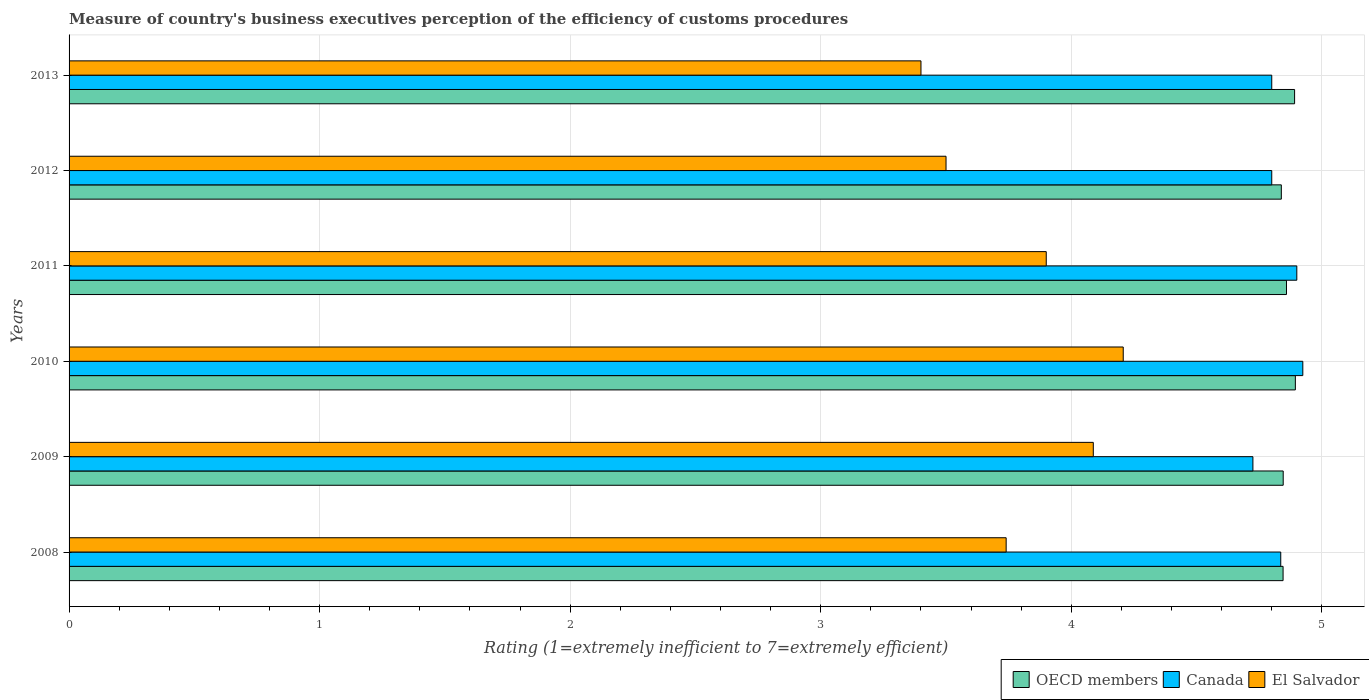How many groups of bars are there?
Provide a short and direct response. 6. Are the number of bars per tick equal to the number of legend labels?
Provide a short and direct response. Yes. In how many cases, is the number of bars for a given year not equal to the number of legend labels?
Give a very brief answer. 0. What is the rating of the efficiency of customs procedure in Canada in 2011?
Your answer should be compact. 4.9. Across all years, what is the maximum rating of the efficiency of customs procedure in Canada?
Keep it short and to the point. 4.92. What is the total rating of the efficiency of customs procedure in El Salvador in the graph?
Give a very brief answer. 22.84. What is the difference between the rating of the efficiency of customs procedure in OECD members in 2009 and that in 2010?
Ensure brevity in your answer.  -0.05. What is the difference between the rating of the efficiency of customs procedure in El Salvador in 2011 and the rating of the efficiency of customs procedure in Canada in 2013?
Provide a succinct answer. -0.9. What is the average rating of the efficiency of customs procedure in El Salvador per year?
Your response must be concise. 3.81. In the year 2010, what is the difference between the rating of the efficiency of customs procedure in OECD members and rating of the efficiency of customs procedure in Canada?
Your response must be concise. -0.03. What is the ratio of the rating of the efficiency of customs procedure in Canada in 2010 to that in 2011?
Give a very brief answer. 1. What is the difference between the highest and the second highest rating of the efficiency of customs procedure in El Salvador?
Provide a succinct answer. 0.12. What is the difference between the highest and the lowest rating of the efficiency of customs procedure in El Salvador?
Offer a very short reply. 0.81. In how many years, is the rating of the efficiency of customs procedure in OECD members greater than the average rating of the efficiency of customs procedure in OECD members taken over all years?
Provide a short and direct response. 2. What does the 2nd bar from the top in 2012 represents?
Your answer should be very brief. Canada. How many bars are there?
Your answer should be compact. 18. How many years are there in the graph?
Provide a succinct answer. 6. Does the graph contain any zero values?
Provide a short and direct response. No. Where does the legend appear in the graph?
Your response must be concise. Bottom right. How many legend labels are there?
Offer a very short reply. 3. What is the title of the graph?
Ensure brevity in your answer.  Measure of country's business executives perception of the efficiency of customs procedures. What is the label or title of the X-axis?
Ensure brevity in your answer.  Rating (1=extremely inefficient to 7=extremely efficient). What is the Rating (1=extremely inefficient to 7=extremely efficient) of OECD members in 2008?
Offer a terse response. 4.85. What is the Rating (1=extremely inefficient to 7=extremely efficient) in Canada in 2008?
Keep it short and to the point. 4.84. What is the Rating (1=extremely inefficient to 7=extremely efficient) in El Salvador in 2008?
Give a very brief answer. 3.74. What is the Rating (1=extremely inefficient to 7=extremely efficient) of OECD members in 2009?
Offer a terse response. 4.85. What is the Rating (1=extremely inefficient to 7=extremely efficient) of Canada in 2009?
Your answer should be very brief. 4.72. What is the Rating (1=extremely inefficient to 7=extremely efficient) of El Salvador in 2009?
Your answer should be compact. 4.09. What is the Rating (1=extremely inefficient to 7=extremely efficient) of OECD members in 2010?
Give a very brief answer. 4.89. What is the Rating (1=extremely inefficient to 7=extremely efficient) in Canada in 2010?
Offer a terse response. 4.92. What is the Rating (1=extremely inefficient to 7=extremely efficient) of El Salvador in 2010?
Offer a very short reply. 4.21. What is the Rating (1=extremely inefficient to 7=extremely efficient) of OECD members in 2011?
Offer a terse response. 4.86. What is the Rating (1=extremely inefficient to 7=extremely efficient) of OECD members in 2012?
Your answer should be very brief. 4.84. What is the Rating (1=extremely inefficient to 7=extremely efficient) in El Salvador in 2012?
Make the answer very short. 3.5. What is the Rating (1=extremely inefficient to 7=extremely efficient) of OECD members in 2013?
Your response must be concise. 4.89. What is the Rating (1=extremely inefficient to 7=extremely efficient) of El Salvador in 2013?
Your response must be concise. 3.4. Across all years, what is the maximum Rating (1=extremely inefficient to 7=extremely efficient) in OECD members?
Your answer should be compact. 4.89. Across all years, what is the maximum Rating (1=extremely inefficient to 7=extremely efficient) of Canada?
Your answer should be compact. 4.92. Across all years, what is the maximum Rating (1=extremely inefficient to 7=extremely efficient) in El Salvador?
Your answer should be compact. 4.21. Across all years, what is the minimum Rating (1=extremely inefficient to 7=extremely efficient) of OECD members?
Give a very brief answer. 4.84. Across all years, what is the minimum Rating (1=extremely inefficient to 7=extremely efficient) of Canada?
Provide a short and direct response. 4.72. Across all years, what is the minimum Rating (1=extremely inefficient to 7=extremely efficient) in El Salvador?
Provide a succinct answer. 3.4. What is the total Rating (1=extremely inefficient to 7=extremely efficient) in OECD members in the graph?
Your response must be concise. 29.17. What is the total Rating (1=extremely inefficient to 7=extremely efficient) in Canada in the graph?
Keep it short and to the point. 28.98. What is the total Rating (1=extremely inefficient to 7=extremely efficient) in El Salvador in the graph?
Your response must be concise. 22.84. What is the difference between the Rating (1=extremely inefficient to 7=extremely efficient) in OECD members in 2008 and that in 2009?
Keep it short and to the point. -0. What is the difference between the Rating (1=extremely inefficient to 7=extremely efficient) of El Salvador in 2008 and that in 2009?
Make the answer very short. -0.35. What is the difference between the Rating (1=extremely inefficient to 7=extremely efficient) of OECD members in 2008 and that in 2010?
Offer a very short reply. -0.05. What is the difference between the Rating (1=extremely inefficient to 7=extremely efficient) in Canada in 2008 and that in 2010?
Keep it short and to the point. -0.09. What is the difference between the Rating (1=extremely inefficient to 7=extremely efficient) of El Salvador in 2008 and that in 2010?
Keep it short and to the point. -0.47. What is the difference between the Rating (1=extremely inefficient to 7=extremely efficient) of OECD members in 2008 and that in 2011?
Your response must be concise. -0.01. What is the difference between the Rating (1=extremely inefficient to 7=extremely efficient) of Canada in 2008 and that in 2011?
Provide a short and direct response. -0.06. What is the difference between the Rating (1=extremely inefficient to 7=extremely efficient) of El Salvador in 2008 and that in 2011?
Make the answer very short. -0.16. What is the difference between the Rating (1=extremely inefficient to 7=extremely efficient) of OECD members in 2008 and that in 2012?
Your answer should be very brief. 0.01. What is the difference between the Rating (1=extremely inefficient to 7=extremely efficient) of Canada in 2008 and that in 2012?
Provide a succinct answer. 0.04. What is the difference between the Rating (1=extremely inefficient to 7=extremely efficient) of El Salvador in 2008 and that in 2012?
Keep it short and to the point. 0.24. What is the difference between the Rating (1=extremely inefficient to 7=extremely efficient) of OECD members in 2008 and that in 2013?
Your answer should be compact. -0.05. What is the difference between the Rating (1=extremely inefficient to 7=extremely efficient) of Canada in 2008 and that in 2013?
Ensure brevity in your answer.  0.04. What is the difference between the Rating (1=extremely inefficient to 7=extremely efficient) in El Salvador in 2008 and that in 2013?
Ensure brevity in your answer.  0.34. What is the difference between the Rating (1=extremely inefficient to 7=extremely efficient) in OECD members in 2009 and that in 2010?
Provide a succinct answer. -0.05. What is the difference between the Rating (1=extremely inefficient to 7=extremely efficient) of Canada in 2009 and that in 2010?
Your answer should be very brief. -0.2. What is the difference between the Rating (1=extremely inefficient to 7=extremely efficient) of El Salvador in 2009 and that in 2010?
Your answer should be compact. -0.12. What is the difference between the Rating (1=extremely inefficient to 7=extremely efficient) in OECD members in 2009 and that in 2011?
Make the answer very short. -0.01. What is the difference between the Rating (1=extremely inefficient to 7=extremely efficient) of Canada in 2009 and that in 2011?
Provide a succinct answer. -0.18. What is the difference between the Rating (1=extremely inefficient to 7=extremely efficient) of El Salvador in 2009 and that in 2011?
Keep it short and to the point. 0.19. What is the difference between the Rating (1=extremely inefficient to 7=extremely efficient) in OECD members in 2009 and that in 2012?
Provide a short and direct response. 0.01. What is the difference between the Rating (1=extremely inefficient to 7=extremely efficient) of Canada in 2009 and that in 2012?
Provide a succinct answer. -0.08. What is the difference between the Rating (1=extremely inefficient to 7=extremely efficient) in El Salvador in 2009 and that in 2012?
Your answer should be compact. 0.59. What is the difference between the Rating (1=extremely inefficient to 7=extremely efficient) of OECD members in 2009 and that in 2013?
Your response must be concise. -0.05. What is the difference between the Rating (1=extremely inefficient to 7=extremely efficient) in Canada in 2009 and that in 2013?
Provide a short and direct response. -0.08. What is the difference between the Rating (1=extremely inefficient to 7=extremely efficient) of El Salvador in 2009 and that in 2013?
Keep it short and to the point. 0.69. What is the difference between the Rating (1=extremely inefficient to 7=extremely efficient) of OECD members in 2010 and that in 2011?
Make the answer very short. 0.04. What is the difference between the Rating (1=extremely inefficient to 7=extremely efficient) in Canada in 2010 and that in 2011?
Offer a terse response. 0.02. What is the difference between the Rating (1=extremely inefficient to 7=extremely efficient) of El Salvador in 2010 and that in 2011?
Offer a terse response. 0.31. What is the difference between the Rating (1=extremely inefficient to 7=extremely efficient) of OECD members in 2010 and that in 2012?
Give a very brief answer. 0.06. What is the difference between the Rating (1=extremely inefficient to 7=extremely efficient) in Canada in 2010 and that in 2012?
Your answer should be compact. 0.12. What is the difference between the Rating (1=extremely inefficient to 7=extremely efficient) of El Salvador in 2010 and that in 2012?
Offer a very short reply. 0.71. What is the difference between the Rating (1=extremely inefficient to 7=extremely efficient) of OECD members in 2010 and that in 2013?
Your answer should be compact. 0. What is the difference between the Rating (1=extremely inefficient to 7=extremely efficient) in Canada in 2010 and that in 2013?
Your response must be concise. 0.12. What is the difference between the Rating (1=extremely inefficient to 7=extremely efficient) of El Salvador in 2010 and that in 2013?
Your answer should be very brief. 0.81. What is the difference between the Rating (1=extremely inefficient to 7=extremely efficient) in OECD members in 2011 and that in 2012?
Your answer should be compact. 0.02. What is the difference between the Rating (1=extremely inefficient to 7=extremely efficient) of El Salvador in 2011 and that in 2012?
Your answer should be compact. 0.4. What is the difference between the Rating (1=extremely inefficient to 7=extremely efficient) in OECD members in 2011 and that in 2013?
Your answer should be compact. -0.03. What is the difference between the Rating (1=extremely inefficient to 7=extremely efficient) of Canada in 2011 and that in 2013?
Offer a terse response. 0.1. What is the difference between the Rating (1=extremely inefficient to 7=extremely efficient) of El Salvador in 2011 and that in 2013?
Provide a succinct answer. 0.5. What is the difference between the Rating (1=extremely inefficient to 7=extremely efficient) of OECD members in 2012 and that in 2013?
Provide a short and direct response. -0.05. What is the difference between the Rating (1=extremely inefficient to 7=extremely efficient) of El Salvador in 2012 and that in 2013?
Your answer should be very brief. 0.1. What is the difference between the Rating (1=extremely inefficient to 7=extremely efficient) in OECD members in 2008 and the Rating (1=extremely inefficient to 7=extremely efficient) in Canada in 2009?
Make the answer very short. 0.12. What is the difference between the Rating (1=extremely inefficient to 7=extremely efficient) in OECD members in 2008 and the Rating (1=extremely inefficient to 7=extremely efficient) in El Salvador in 2009?
Offer a very short reply. 0.76. What is the difference between the Rating (1=extremely inefficient to 7=extremely efficient) in Canada in 2008 and the Rating (1=extremely inefficient to 7=extremely efficient) in El Salvador in 2009?
Offer a terse response. 0.75. What is the difference between the Rating (1=extremely inefficient to 7=extremely efficient) of OECD members in 2008 and the Rating (1=extremely inefficient to 7=extremely efficient) of Canada in 2010?
Offer a terse response. -0.08. What is the difference between the Rating (1=extremely inefficient to 7=extremely efficient) of OECD members in 2008 and the Rating (1=extremely inefficient to 7=extremely efficient) of El Salvador in 2010?
Your response must be concise. 0.64. What is the difference between the Rating (1=extremely inefficient to 7=extremely efficient) in Canada in 2008 and the Rating (1=extremely inefficient to 7=extremely efficient) in El Salvador in 2010?
Offer a terse response. 0.63. What is the difference between the Rating (1=extremely inefficient to 7=extremely efficient) of OECD members in 2008 and the Rating (1=extremely inefficient to 7=extremely efficient) of Canada in 2011?
Offer a very short reply. -0.05. What is the difference between the Rating (1=extremely inefficient to 7=extremely efficient) in OECD members in 2008 and the Rating (1=extremely inefficient to 7=extremely efficient) in El Salvador in 2011?
Give a very brief answer. 0.95. What is the difference between the Rating (1=extremely inefficient to 7=extremely efficient) of Canada in 2008 and the Rating (1=extremely inefficient to 7=extremely efficient) of El Salvador in 2011?
Your response must be concise. 0.94. What is the difference between the Rating (1=extremely inefficient to 7=extremely efficient) of OECD members in 2008 and the Rating (1=extremely inefficient to 7=extremely efficient) of Canada in 2012?
Ensure brevity in your answer.  0.05. What is the difference between the Rating (1=extremely inefficient to 7=extremely efficient) of OECD members in 2008 and the Rating (1=extremely inefficient to 7=extremely efficient) of El Salvador in 2012?
Provide a short and direct response. 1.35. What is the difference between the Rating (1=extremely inefficient to 7=extremely efficient) in Canada in 2008 and the Rating (1=extremely inefficient to 7=extremely efficient) in El Salvador in 2012?
Your answer should be compact. 1.34. What is the difference between the Rating (1=extremely inefficient to 7=extremely efficient) of OECD members in 2008 and the Rating (1=extremely inefficient to 7=extremely efficient) of Canada in 2013?
Offer a terse response. 0.05. What is the difference between the Rating (1=extremely inefficient to 7=extremely efficient) in OECD members in 2008 and the Rating (1=extremely inefficient to 7=extremely efficient) in El Salvador in 2013?
Make the answer very short. 1.45. What is the difference between the Rating (1=extremely inefficient to 7=extremely efficient) in Canada in 2008 and the Rating (1=extremely inefficient to 7=extremely efficient) in El Salvador in 2013?
Provide a succinct answer. 1.44. What is the difference between the Rating (1=extremely inefficient to 7=extremely efficient) of OECD members in 2009 and the Rating (1=extremely inefficient to 7=extremely efficient) of Canada in 2010?
Provide a succinct answer. -0.08. What is the difference between the Rating (1=extremely inefficient to 7=extremely efficient) of OECD members in 2009 and the Rating (1=extremely inefficient to 7=extremely efficient) of El Salvador in 2010?
Provide a short and direct response. 0.64. What is the difference between the Rating (1=extremely inefficient to 7=extremely efficient) of Canada in 2009 and the Rating (1=extremely inefficient to 7=extremely efficient) of El Salvador in 2010?
Ensure brevity in your answer.  0.52. What is the difference between the Rating (1=extremely inefficient to 7=extremely efficient) in OECD members in 2009 and the Rating (1=extremely inefficient to 7=extremely efficient) in Canada in 2011?
Keep it short and to the point. -0.05. What is the difference between the Rating (1=extremely inefficient to 7=extremely efficient) in OECD members in 2009 and the Rating (1=extremely inefficient to 7=extremely efficient) in El Salvador in 2011?
Offer a terse response. 0.95. What is the difference between the Rating (1=extremely inefficient to 7=extremely efficient) in Canada in 2009 and the Rating (1=extremely inefficient to 7=extremely efficient) in El Salvador in 2011?
Your answer should be compact. 0.82. What is the difference between the Rating (1=extremely inefficient to 7=extremely efficient) in OECD members in 2009 and the Rating (1=extremely inefficient to 7=extremely efficient) in Canada in 2012?
Your answer should be compact. 0.05. What is the difference between the Rating (1=extremely inefficient to 7=extremely efficient) in OECD members in 2009 and the Rating (1=extremely inefficient to 7=extremely efficient) in El Salvador in 2012?
Your answer should be very brief. 1.35. What is the difference between the Rating (1=extremely inefficient to 7=extremely efficient) of Canada in 2009 and the Rating (1=extremely inefficient to 7=extremely efficient) of El Salvador in 2012?
Provide a succinct answer. 1.22. What is the difference between the Rating (1=extremely inefficient to 7=extremely efficient) in OECD members in 2009 and the Rating (1=extremely inefficient to 7=extremely efficient) in Canada in 2013?
Give a very brief answer. 0.05. What is the difference between the Rating (1=extremely inefficient to 7=extremely efficient) in OECD members in 2009 and the Rating (1=extremely inefficient to 7=extremely efficient) in El Salvador in 2013?
Offer a very short reply. 1.45. What is the difference between the Rating (1=extremely inefficient to 7=extremely efficient) in Canada in 2009 and the Rating (1=extremely inefficient to 7=extremely efficient) in El Salvador in 2013?
Keep it short and to the point. 1.32. What is the difference between the Rating (1=extremely inefficient to 7=extremely efficient) of OECD members in 2010 and the Rating (1=extremely inefficient to 7=extremely efficient) of Canada in 2011?
Give a very brief answer. -0.01. What is the difference between the Rating (1=extremely inefficient to 7=extremely efficient) in OECD members in 2010 and the Rating (1=extremely inefficient to 7=extremely efficient) in El Salvador in 2011?
Your response must be concise. 0.99. What is the difference between the Rating (1=extremely inefficient to 7=extremely efficient) of Canada in 2010 and the Rating (1=extremely inefficient to 7=extremely efficient) of El Salvador in 2011?
Give a very brief answer. 1.02. What is the difference between the Rating (1=extremely inefficient to 7=extremely efficient) in OECD members in 2010 and the Rating (1=extremely inefficient to 7=extremely efficient) in Canada in 2012?
Provide a succinct answer. 0.09. What is the difference between the Rating (1=extremely inefficient to 7=extremely efficient) of OECD members in 2010 and the Rating (1=extremely inefficient to 7=extremely efficient) of El Salvador in 2012?
Keep it short and to the point. 1.39. What is the difference between the Rating (1=extremely inefficient to 7=extremely efficient) in Canada in 2010 and the Rating (1=extremely inefficient to 7=extremely efficient) in El Salvador in 2012?
Keep it short and to the point. 1.42. What is the difference between the Rating (1=extremely inefficient to 7=extremely efficient) in OECD members in 2010 and the Rating (1=extremely inefficient to 7=extremely efficient) in Canada in 2013?
Make the answer very short. 0.09. What is the difference between the Rating (1=extremely inefficient to 7=extremely efficient) of OECD members in 2010 and the Rating (1=extremely inefficient to 7=extremely efficient) of El Salvador in 2013?
Offer a terse response. 1.49. What is the difference between the Rating (1=extremely inefficient to 7=extremely efficient) of Canada in 2010 and the Rating (1=extremely inefficient to 7=extremely efficient) of El Salvador in 2013?
Provide a succinct answer. 1.52. What is the difference between the Rating (1=extremely inefficient to 7=extremely efficient) of OECD members in 2011 and the Rating (1=extremely inefficient to 7=extremely efficient) of Canada in 2012?
Make the answer very short. 0.06. What is the difference between the Rating (1=extremely inefficient to 7=extremely efficient) in OECD members in 2011 and the Rating (1=extremely inefficient to 7=extremely efficient) in El Salvador in 2012?
Your answer should be very brief. 1.36. What is the difference between the Rating (1=extremely inefficient to 7=extremely efficient) of Canada in 2011 and the Rating (1=extremely inefficient to 7=extremely efficient) of El Salvador in 2012?
Ensure brevity in your answer.  1.4. What is the difference between the Rating (1=extremely inefficient to 7=extremely efficient) of OECD members in 2011 and the Rating (1=extremely inefficient to 7=extremely efficient) of Canada in 2013?
Give a very brief answer. 0.06. What is the difference between the Rating (1=extremely inefficient to 7=extremely efficient) of OECD members in 2011 and the Rating (1=extremely inefficient to 7=extremely efficient) of El Salvador in 2013?
Ensure brevity in your answer.  1.46. What is the difference between the Rating (1=extremely inefficient to 7=extremely efficient) of Canada in 2011 and the Rating (1=extremely inefficient to 7=extremely efficient) of El Salvador in 2013?
Offer a very short reply. 1.5. What is the difference between the Rating (1=extremely inefficient to 7=extremely efficient) of OECD members in 2012 and the Rating (1=extremely inefficient to 7=extremely efficient) of Canada in 2013?
Offer a terse response. 0.04. What is the difference between the Rating (1=extremely inefficient to 7=extremely efficient) in OECD members in 2012 and the Rating (1=extremely inefficient to 7=extremely efficient) in El Salvador in 2013?
Keep it short and to the point. 1.44. What is the difference between the Rating (1=extremely inefficient to 7=extremely efficient) of Canada in 2012 and the Rating (1=extremely inefficient to 7=extremely efficient) of El Salvador in 2013?
Offer a terse response. 1.4. What is the average Rating (1=extremely inefficient to 7=extremely efficient) of OECD members per year?
Your answer should be compact. 4.86. What is the average Rating (1=extremely inefficient to 7=extremely efficient) in Canada per year?
Give a very brief answer. 4.83. What is the average Rating (1=extremely inefficient to 7=extremely efficient) of El Salvador per year?
Ensure brevity in your answer.  3.81. In the year 2008, what is the difference between the Rating (1=extremely inefficient to 7=extremely efficient) in OECD members and Rating (1=extremely inefficient to 7=extremely efficient) in Canada?
Keep it short and to the point. 0.01. In the year 2008, what is the difference between the Rating (1=extremely inefficient to 7=extremely efficient) in OECD members and Rating (1=extremely inefficient to 7=extremely efficient) in El Salvador?
Ensure brevity in your answer.  1.11. In the year 2008, what is the difference between the Rating (1=extremely inefficient to 7=extremely efficient) of Canada and Rating (1=extremely inefficient to 7=extremely efficient) of El Salvador?
Ensure brevity in your answer.  1.1. In the year 2009, what is the difference between the Rating (1=extremely inefficient to 7=extremely efficient) of OECD members and Rating (1=extremely inefficient to 7=extremely efficient) of Canada?
Your answer should be compact. 0.12. In the year 2009, what is the difference between the Rating (1=extremely inefficient to 7=extremely efficient) of OECD members and Rating (1=extremely inefficient to 7=extremely efficient) of El Salvador?
Provide a short and direct response. 0.76. In the year 2009, what is the difference between the Rating (1=extremely inefficient to 7=extremely efficient) of Canada and Rating (1=extremely inefficient to 7=extremely efficient) of El Salvador?
Offer a terse response. 0.64. In the year 2010, what is the difference between the Rating (1=extremely inefficient to 7=extremely efficient) of OECD members and Rating (1=extremely inefficient to 7=extremely efficient) of Canada?
Offer a very short reply. -0.03. In the year 2010, what is the difference between the Rating (1=extremely inefficient to 7=extremely efficient) of OECD members and Rating (1=extremely inefficient to 7=extremely efficient) of El Salvador?
Keep it short and to the point. 0.69. In the year 2010, what is the difference between the Rating (1=extremely inefficient to 7=extremely efficient) in Canada and Rating (1=extremely inefficient to 7=extremely efficient) in El Salvador?
Keep it short and to the point. 0.72. In the year 2011, what is the difference between the Rating (1=extremely inefficient to 7=extremely efficient) of OECD members and Rating (1=extremely inefficient to 7=extremely efficient) of Canada?
Ensure brevity in your answer.  -0.04. In the year 2011, what is the difference between the Rating (1=extremely inefficient to 7=extremely efficient) of OECD members and Rating (1=extremely inefficient to 7=extremely efficient) of El Salvador?
Your response must be concise. 0.96. In the year 2012, what is the difference between the Rating (1=extremely inefficient to 7=extremely efficient) of OECD members and Rating (1=extremely inefficient to 7=extremely efficient) of Canada?
Your response must be concise. 0.04. In the year 2012, what is the difference between the Rating (1=extremely inefficient to 7=extremely efficient) in OECD members and Rating (1=extremely inefficient to 7=extremely efficient) in El Salvador?
Give a very brief answer. 1.34. In the year 2013, what is the difference between the Rating (1=extremely inefficient to 7=extremely efficient) of OECD members and Rating (1=extremely inefficient to 7=extremely efficient) of Canada?
Your answer should be very brief. 0.09. In the year 2013, what is the difference between the Rating (1=extremely inefficient to 7=extremely efficient) of OECD members and Rating (1=extremely inefficient to 7=extremely efficient) of El Salvador?
Your answer should be very brief. 1.49. In the year 2013, what is the difference between the Rating (1=extremely inefficient to 7=extremely efficient) of Canada and Rating (1=extremely inefficient to 7=extremely efficient) of El Salvador?
Your response must be concise. 1.4. What is the ratio of the Rating (1=extremely inefficient to 7=extremely efficient) in Canada in 2008 to that in 2009?
Provide a succinct answer. 1.02. What is the ratio of the Rating (1=extremely inefficient to 7=extremely efficient) in El Salvador in 2008 to that in 2009?
Provide a succinct answer. 0.91. What is the ratio of the Rating (1=extremely inefficient to 7=extremely efficient) of OECD members in 2008 to that in 2010?
Keep it short and to the point. 0.99. What is the ratio of the Rating (1=extremely inefficient to 7=extremely efficient) in Canada in 2008 to that in 2010?
Keep it short and to the point. 0.98. What is the ratio of the Rating (1=extremely inefficient to 7=extremely efficient) of Canada in 2008 to that in 2011?
Offer a terse response. 0.99. What is the ratio of the Rating (1=extremely inefficient to 7=extremely efficient) in Canada in 2008 to that in 2012?
Make the answer very short. 1.01. What is the ratio of the Rating (1=extremely inefficient to 7=extremely efficient) in El Salvador in 2008 to that in 2012?
Offer a terse response. 1.07. What is the ratio of the Rating (1=extremely inefficient to 7=extremely efficient) in OECD members in 2008 to that in 2013?
Your response must be concise. 0.99. What is the ratio of the Rating (1=extremely inefficient to 7=extremely efficient) in Canada in 2008 to that in 2013?
Your response must be concise. 1.01. What is the ratio of the Rating (1=extremely inefficient to 7=extremely efficient) in Canada in 2009 to that in 2010?
Provide a succinct answer. 0.96. What is the ratio of the Rating (1=extremely inefficient to 7=extremely efficient) of El Salvador in 2009 to that in 2010?
Give a very brief answer. 0.97. What is the ratio of the Rating (1=extremely inefficient to 7=extremely efficient) of Canada in 2009 to that in 2011?
Offer a very short reply. 0.96. What is the ratio of the Rating (1=extremely inefficient to 7=extremely efficient) in El Salvador in 2009 to that in 2011?
Keep it short and to the point. 1.05. What is the ratio of the Rating (1=extremely inefficient to 7=extremely efficient) of OECD members in 2009 to that in 2012?
Your answer should be very brief. 1. What is the ratio of the Rating (1=extremely inefficient to 7=extremely efficient) of Canada in 2009 to that in 2012?
Give a very brief answer. 0.98. What is the ratio of the Rating (1=extremely inefficient to 7=extremely efficient) of El Salvador in 2009 to that in 2012?
Your answer should be compact. 1.17. What is the ratio of the Rating (1=extremely inefficient to 7=extremely efficient) of OECD members in 2009 to that in 2013?
Offer a terse response. 0.99. What is the ratio of the Rating (1=extremely inefficient to 7=extremely efficient) of Canada in 2009 to that in 2013?
Offer a very short reply. 0.98. What is the ratio of the Rating (1=extremely inefficient to 7=extremely efficient) of El Salvador in 2009 to that in 2013?
Give a very brief answer. 1.2. What is the ratio of the Rating (1=extremely inefficient to 7=extremely efficient) in OECD members in 2010 to that in 2011?
Make the answer very short. 1.01. What is the ratio of the Rating (1=extremely inefficient to 7=extremely efficient) in Canada in 2010 to that in 2011?
Offer a terse response. 1. What is the ratio of the Rating (1=extremely inefficient to 7=extremely efficient) in El Salvador in 2010 to that in 2011?
Offer a terse response. 1.08. What is the ratio of the Rating (1=extremely inefficient to 7=extremely efficient) of OECD members in 2010 to that in 2012?
Offer a terse response. 1.01. What is the ratio of the Rating (1=extremely inefficient to 7=extremely efficient) in Canada in 2010 to that in 2012?
Offer a terse response. 1.03. What is the ratio of the Rating (1=extremely inefficient to 7=extremely efficient) of El Salvador in 2010 to that in 2012?
Give a very brief answer. 1.2. What is the ratio of the Rating (1=extremely inefficient to 7=extremely efficient) in Canada in 2010 to that in 2013?
Your answer should be very brief. 1.03. What is the ratio of the Rating (1=extremely inefficient to 7=extremely efficient) in El Salvador in 2010 to that in 2013?
Provide a short and direct response. 1.24. What is the ratio of the Rating (1=extremely inefficient to 7=extremely efficient) in Canada in 2011 to that in 2012?
Keep it short and to the point. 1.02. What is the ratio of the Rating (1=extremely inefficient to 7=extremely efficient) of El Salvador in 2011 to that in 2012?
Offer a very short reply. 1.11. What is the ratio of the Rating (1=extremely inefficient to 7=extremely efficient) of Canada in 2011 to that in 2013?
Keep it short and to the point. 1.02. What is the ratio of the Rating (1=extremely inefficient to 7=extremely efficient) in El Salvador in 2011 to that in 2013?
Provide a short and direct response. 1.15. What is the ratio of the Rating (1=extremely inefficient to 7=extremely efficient) in Canada in 2012 to that in 2013?
Your answer should be compact. 1. What is the ratio of the Rating (1=extremely inefficient to 7=extremely efficient) in El Salvador in 2012 to that in 2013?
Keep it short and to the point. 1.03. What is the difference between the highest and the second highest Rating (1=extremely inefficient to 7=extremely efficient) of OECD members?
Give a very brief answer. 0. What is the difference between the highest and the second highest Rating (1=extremely inefficient to 7=extremely efficient) of Canada?
Keep it short and to the point. 0.02. What is the difference between the highest and the second highest Rating (1=extremely inefficient to 7=extremely efficient) in El Salvador?
Offer a terse response. 0.12. What is the difference between the highest and the lowest Rating (1=extremely inefficient to 7=extremely efficient) of OECD members?
Your answer should be compact. 0.06. What is the difference between the highest and the lowest Rating (1=extremely inefficient to 7=extremely efficient) in Canada?
Your response must be concise. 0.2. What is the difference between the highest and the lowest Rating (1=extremely inefficient to 7=extremely efficient) in El Salvador?
Your response must be concise. 0.81. 